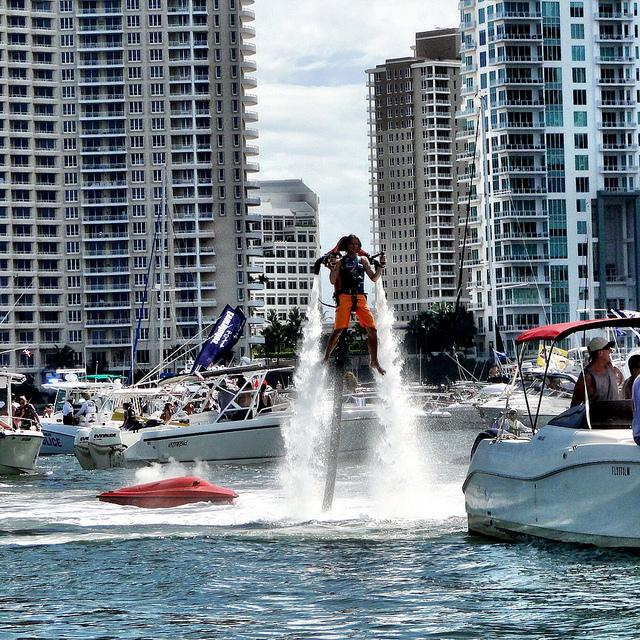What power allows the man to to airborne? Please explain your reasoning. water pump. A man is in the air with a contraption that is spitting out water below him. 